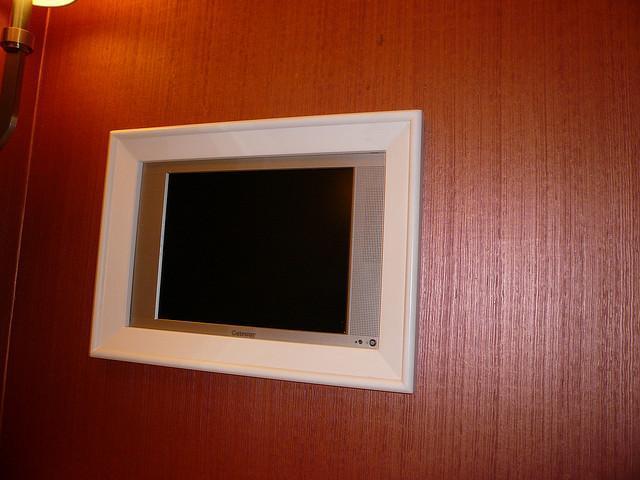How many elephant feet are lifted?
Give a very brief answer. 0. 